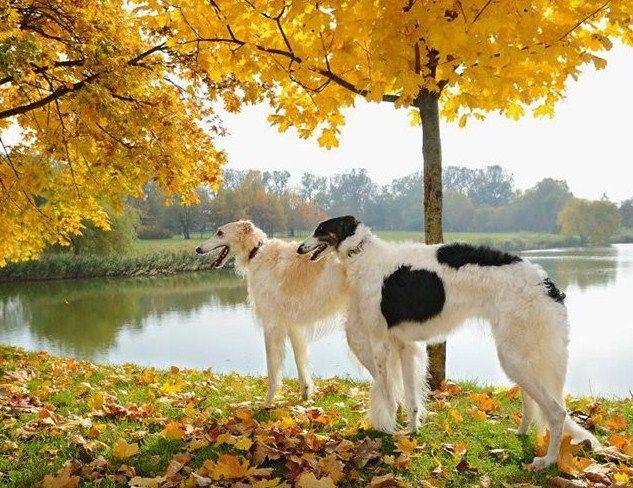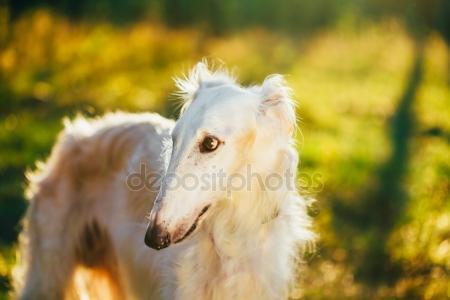The first image is the image on the left, the second image is the image on the right. Assess this claim about the two images: "At least one dog wears a collar with no leash.". Correct or not? Answer yes or no. Yes. 